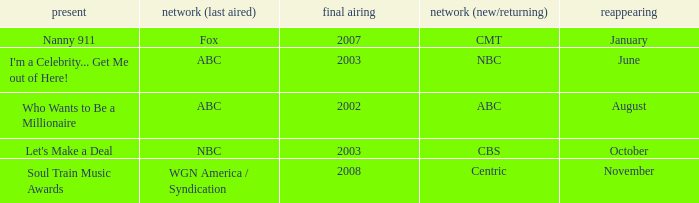When did a show last aired in 2002 return? August. Parse the full table. {'header': ['present', 'network (last aired)', 'final airing', 'network (new/returning)', 'reappearing'], 'rows': [['Nanny 911', 'Fox', '2007', 'CMT', 'January'], ["I'm a Celebrity... Get Me out of Here!", 'ABC', '2003', 'NBC', 'June'], ['Who Wants to Be a Millionaire', 'ABC', '2002', 'ABC', 'August'], ["Let's Make a Deal", 'NBC', '2003', 'CBS', 'October'], ['Soul Train Music Awards', 'WGN America / Syndication', '2008', 'Centric', 'November']]} 